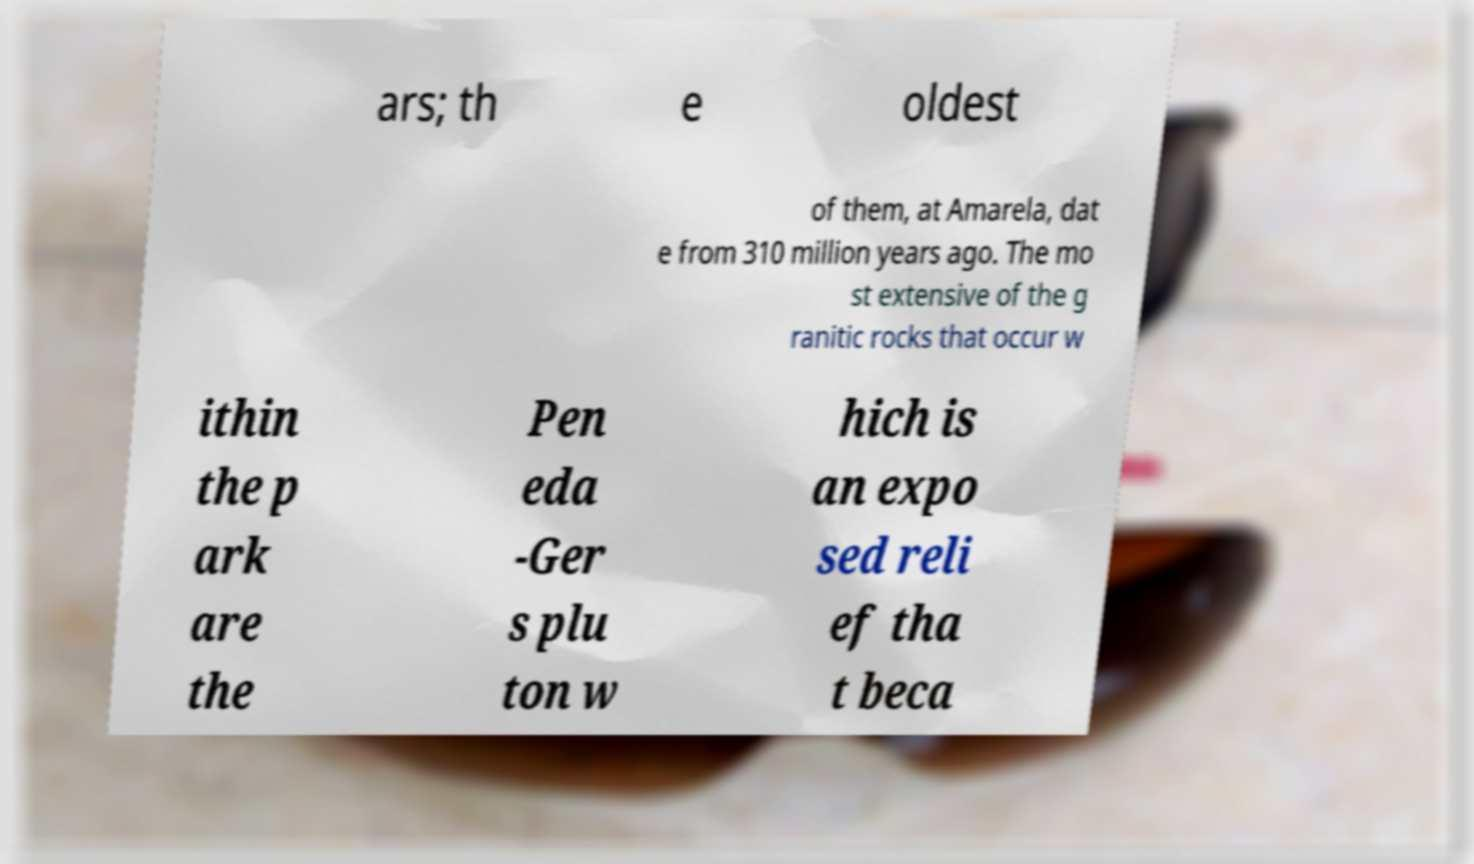What messages or text are displayed in this image? I need them in a readable, typed format. ars; th e oldest of them, at Amarela, dat e from 310 million years ago. The mo st extensive of the g ranitic rocks that occur w ithin the p ark are the Pen eda -Ger s plu ton w hich is an expo sed reli ef tha t beca 